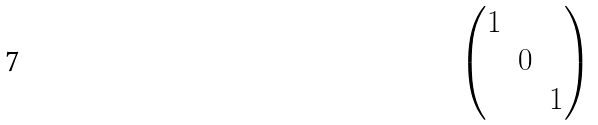Convert formula to latex. <formula><loc_0><loc_0><loc_500><loc_500>\begin{pmatrix} 1 & & \\ & 0 & \\ & & 1 \end{pmatrix}</formula> 